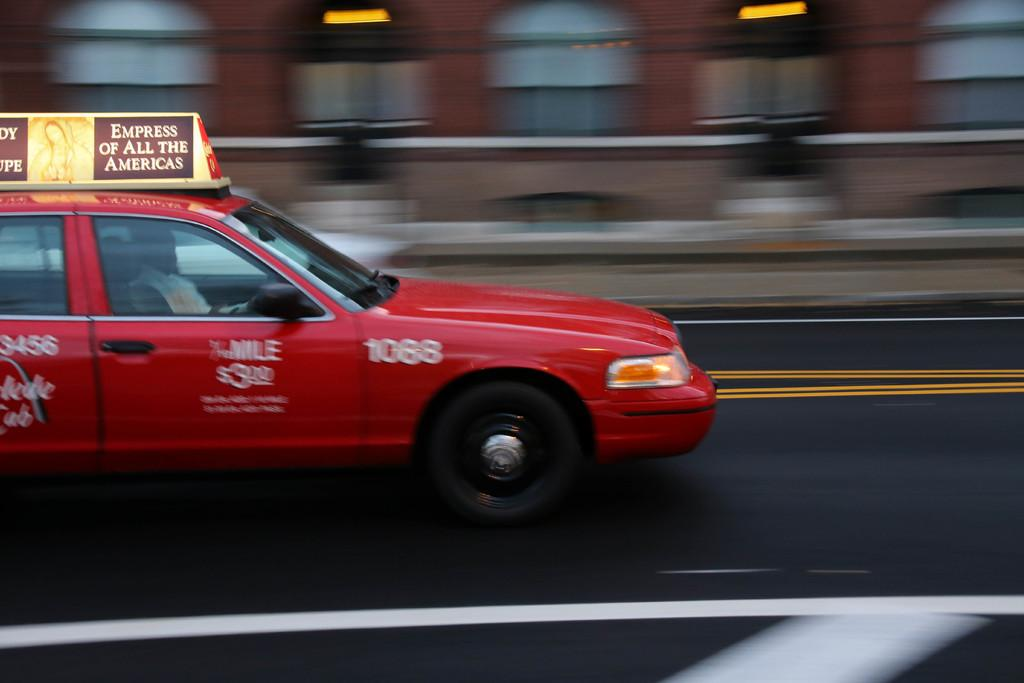<image>
Give a short and clear explanation of the subsequent image. The number on the side of this red taxi is 1088. 